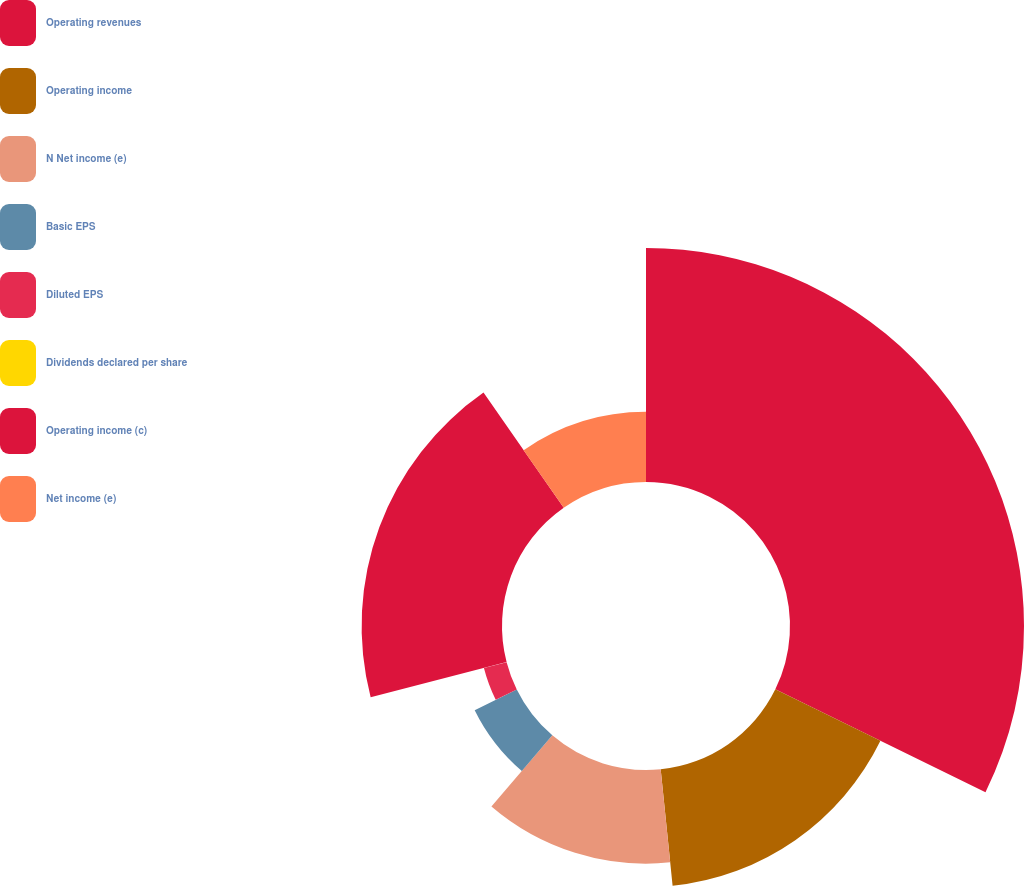Convert chart. <chart><loc_0><loc_0><loc_500><loc_500><pie_chart><fcel>Operating revenues<fcel>Operating income<fcel>N Net income (e)<fcel>Basic EPS<fcel>Diluted EPS<fcel>Dividends declared per share<fcel>Operating income (c)<fcel>Net income (e)<nl><fcel>32.25%<fcel>16.13%<fcel>12.9%<fcel>6.46%<fcel>3.23%<fcel>0.01%<fcel>19.35%<fcel>9.68%<nl></chart> 